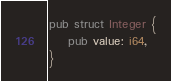Convert code to text. <code><loc_0><loc_0><loc_500><loc_500><_Rust_>pub struct Integer {
    pub value: i64,
}</code> 